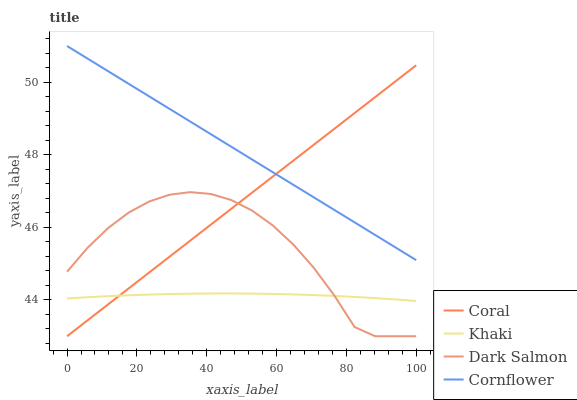Does Coral have the minimum area under the curve?
Answer yes or no. No. Does Coral have the maximum area under the curve?
Answer yes or no. No. Is Khaki the smoothest?
Answer yes or no. No. Is Khaki the roughest?
Answer yes or no. No. Does Khaki have the lowest value?
Answer yes or no. No. Does Coral have the highest value?
Answer yes or no. No. Is Dark Salmon less than Cornflower?
Answer yes or no. Yes. Is Cornflower greater than Dark Salmon?
Answer yes or no. Yes. Does Dark Salmon intersect Cornflower?
Answer yes or no. No. 